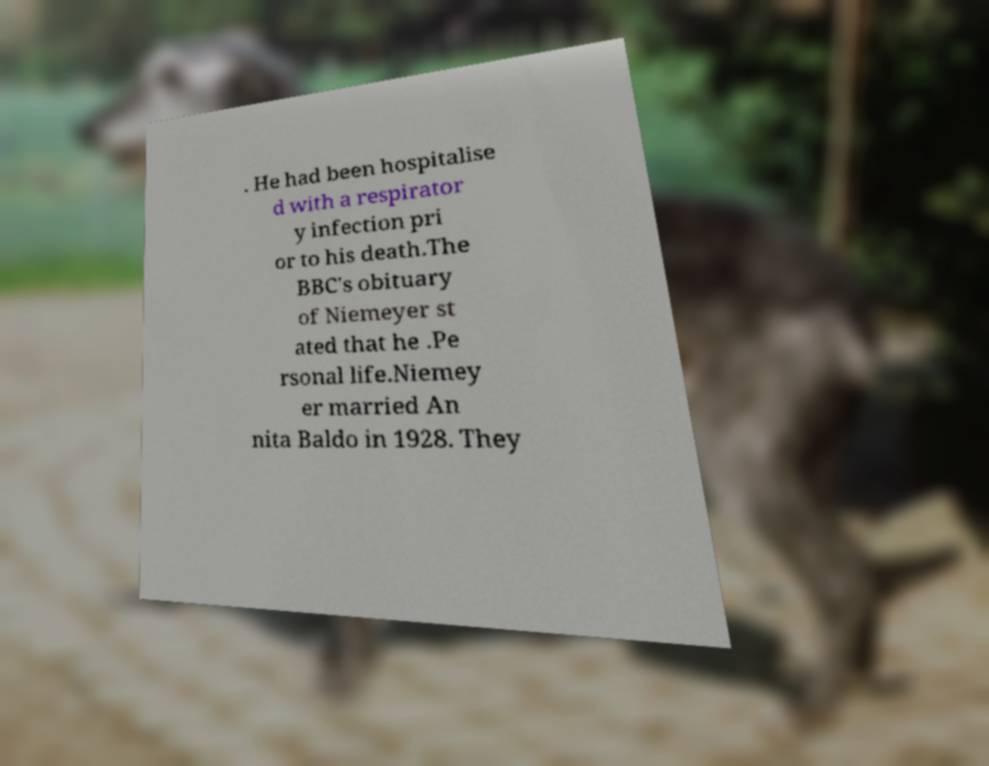Can you accurately transcribe the text from the provided image for me? . He had been hospitalise d with a respirator y infection pri or to his death.The BBC's obituary of Niemeyer st ated that he .Pe rsonal life.Niemey er married An nita Baldo in 1928. They 